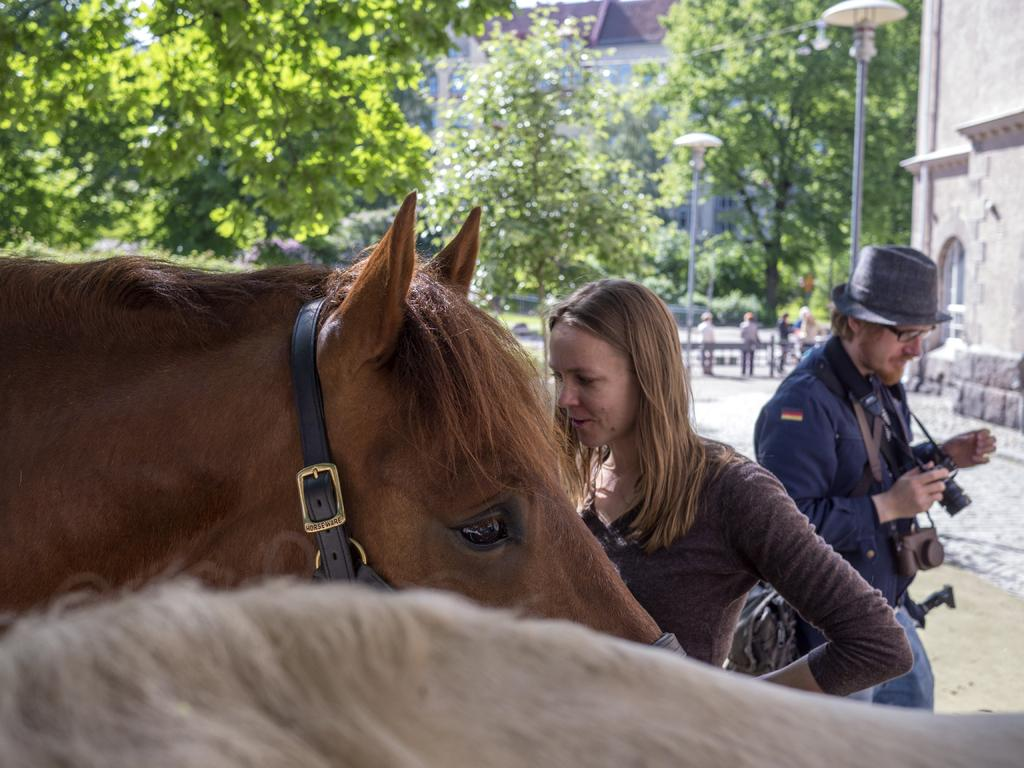What is the woman doing in the image? The woman is standing in front of a horse. Can you describe the person with the blue shirt? The person with the blue shirt is carrying a camera. What can be seen in the background of the image? There is a building and trees in the background of the image. How does the woman feel about the comfort of the horse's saddle in the image? There is no information about the comfort of the horse's saddle in the image, so it cannot be determined how the woman feels about it. 